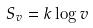Convert formula to latex. <formula><loc_0><loc_0><loc_500><loc_500>S _ { v } = k \log v</formula> 